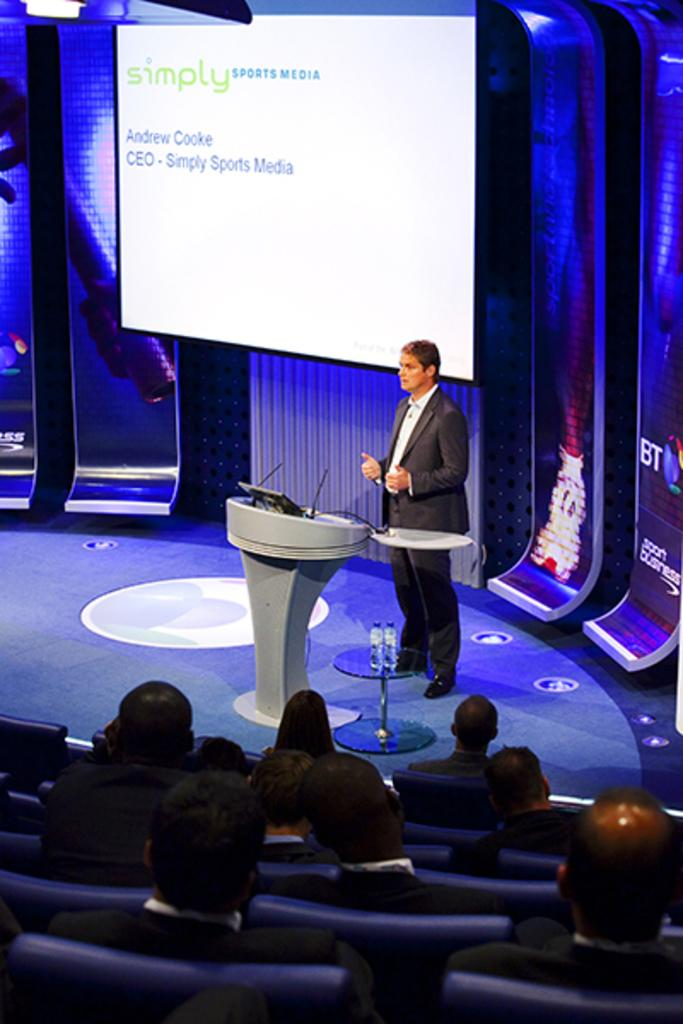What is the main subject in the middle of the image? There is a man standing in the middle of the image. What is the man wearing? The man is wearing a coat and trousers. What can be seen at the top of the image? There is a projector screen at the top of the image. What are the people in the lower part of the image doing? There are people sitting on chairs in the lower part of the image. What type of furniture can be seen on the edge of the image? There is no furniture visible on the edge of the image. What kind of cart is being used by the people in the image? There is no cart present in the image. 